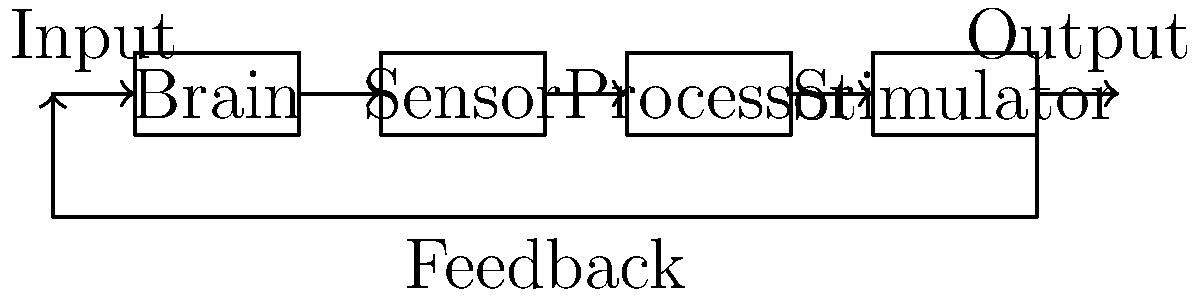In the closed-loop deep brain stimulation system shown above for treatment-resistant depression, which component is responsible for analyzing the brain's electrical activity and determining the appropriate stimulation parameters? To answer this question, let's analyze the components of the closed-loop deep brain stimulation system:

1. Brain: This is the target organ that receives stimulation and produces electrical activity.

2. Sensor: This component detects and measures the electrical activity in the brain.

3. Processor: This is the central component that analyzes the data from the sensor and makes decisions about stimulation.

4. Stimulator: This component delivers the electrical stimulation to the brain based on the processor's instructions.

5. Feedback loop: This connects the output back to the input, allowing the system to adjust based on the brain's response.

The key to a closed-loop system is the ability to analyze the brain's activity and adjust the stimulation accordingly. In this system, the component responsible for this analysis and decision-making is the Processor.

The Processor receives data from the Sensor, which detects the brain's electrical activity. It then analyzes this data to determine the current state of the brain and decides on the appropriate stimulation parameters. These parameters are then sent to the Stimulator for delivery to the brain.

This adaptive approach allows the system to respond dynamically to changes in the patient's brain activity, potentially improving the efficacy of the treatment for depression.
Answer: Processor 